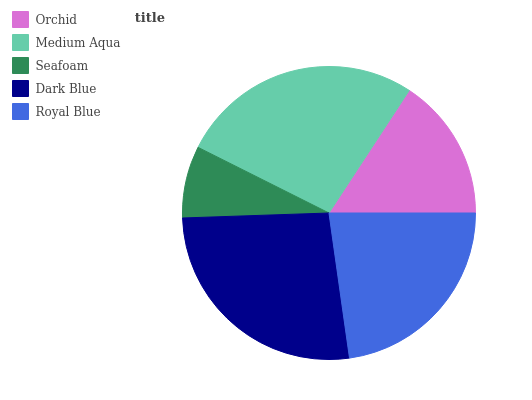Is Seafoam the minimum?
Answer yes or no. Yes. Is Medium Aqua the maximum?
Answer yes or no. Yes. Is Medium Aqua the minimum?
Answer yes or no. No. Is Seafoam the maximum?
Answer yes or no. No. Is Medium Aqua greater than Seafoam?
Answer yes or no. Yes. Is Seafoam less than Medium Aqua?
Answer yes or no. Yes. Is Seafoam greater than Medium Aqua?
Answer yes or no. No. Is Medium Aqua less than Seafoam?
Answer yes or no. No. Is Royal Blue the high median?
Answer yes or no. Yes. Is Royal Blue the low median?
Answer yes or no. Yes. Is Dark Blue the high median?
Answer yes or no. No. Is Dark Blue the low median?
Answer yes or no. No. 